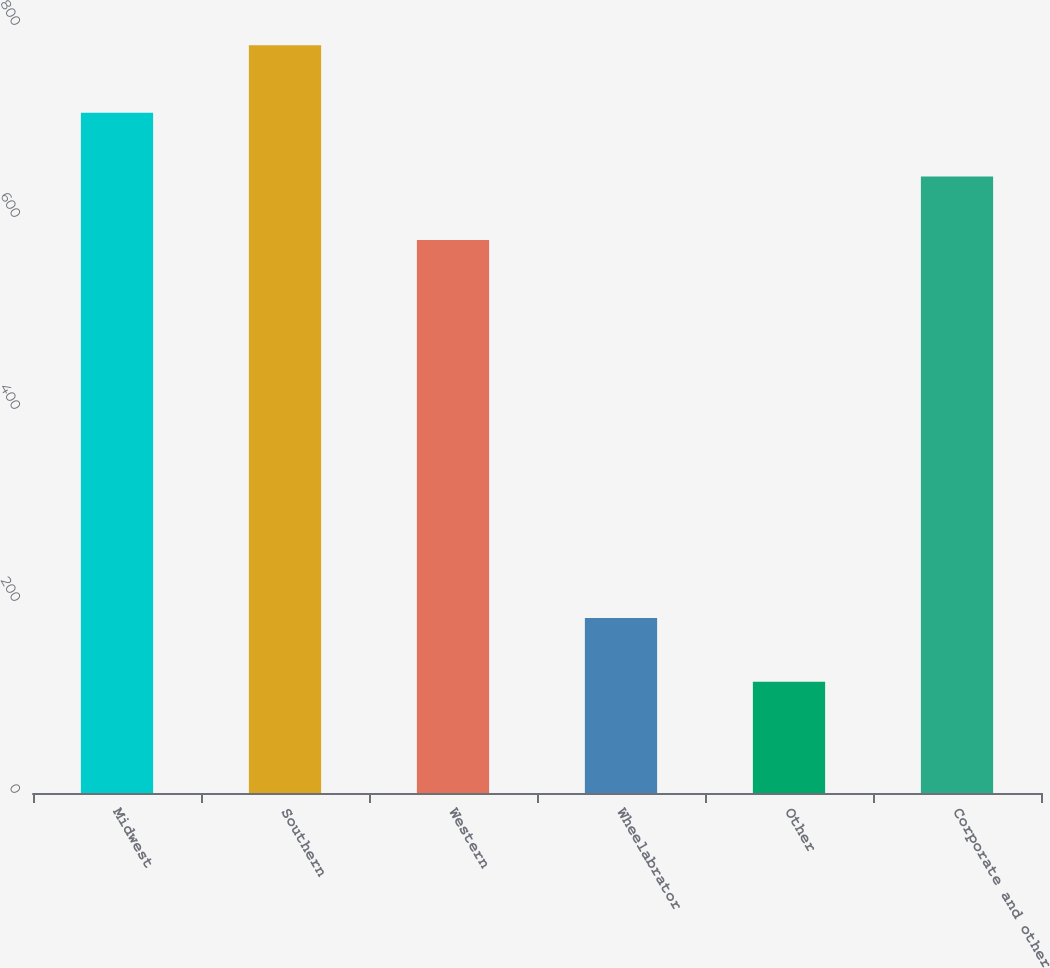<chart> <loc_0><loc_0><loc_500><loc_500><bar_chart><fcel>Midwest<fcel>Southern<fcel>Western<fcel>Wheelabrator<fcel>Other<fcel>Corporate and other<nl><fcel>708.6<fcel>779<fcel>576<fcel>182.3<fcel>116<fcel>642.3<nl></chart> 